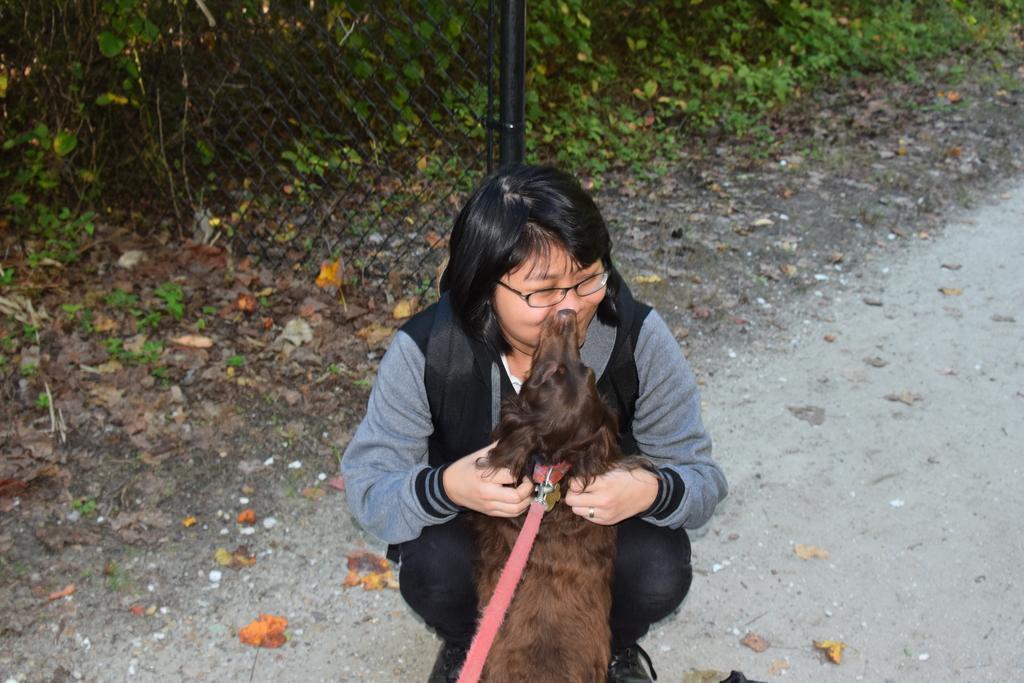Please provide a concise description of this image. As we can see in the image there are trees, fence, some leaves on road and the women who is sitting over here is wearing black color dress and holding a dog 